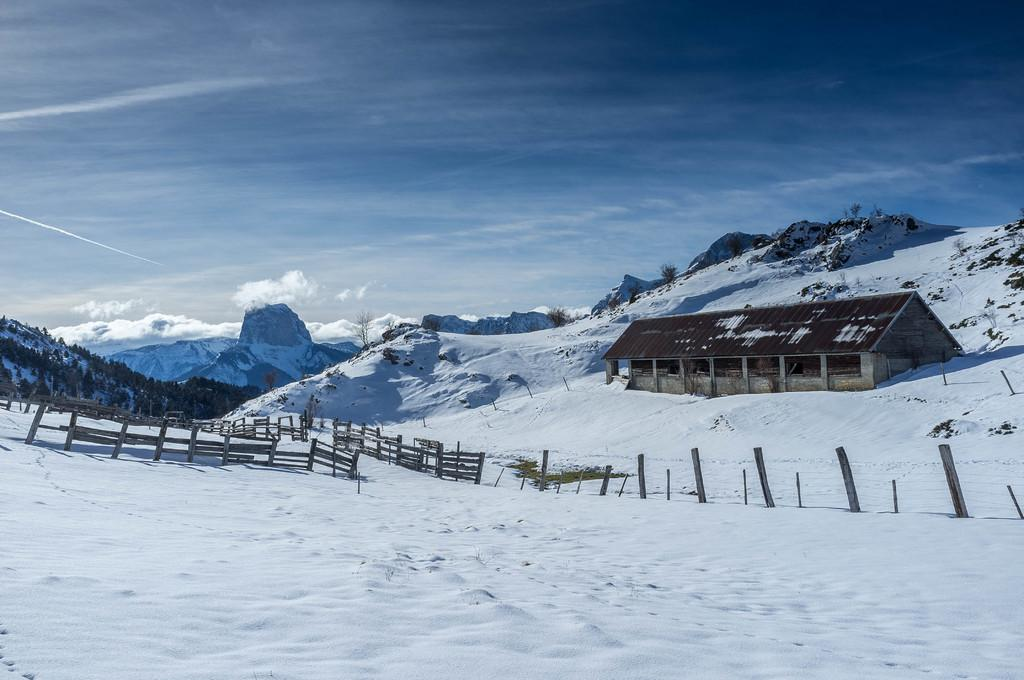What type of structure is present in the image? There is a house in the image. What natural features can be seen in the background? There are mountains and trees in the image. What type of barrier is present near the house? There is a wooden fence in the image. What is visible in the sky? The sky is visible in the image, and there are clouds present. What weather condition can be inferred from the presence of snow in the image? The presence of snow suggests that it is cold or possibly winter in the image. How many oranges are hanging from the trees in the image? There are no oranges present in the image; it features trees without fruit. What type of farm can be seen in the image? There is no farm present in the image; it features a house, mountains, trees, and a wooden fence. 